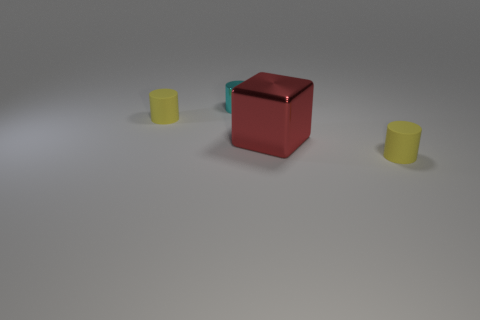Subtract all metallic cylinders. How many cylinders are left? 2 Add 2 large yellow metal objects. How many objects exist? 6 Subtract all cyan cylinders. How many cylinders are left? 2 Subtract all cylinders. How many objects are left? 1 Add 1 large yellow blocks. How many large yellow blocks exist? 1 Subtract 0 blue spheres. How many objects are left? 4 Subtract 3 cylinders. How many cylinders are left? 0 Subtract all green cylinders. Subtract all purple blocks. How many cylinders are left? 3 Subtract all brown blocks. How many red cylinders are left? 0 Subtract all yellow matte objects. Subtract all yellow rubber things. How many objects are left? 0 